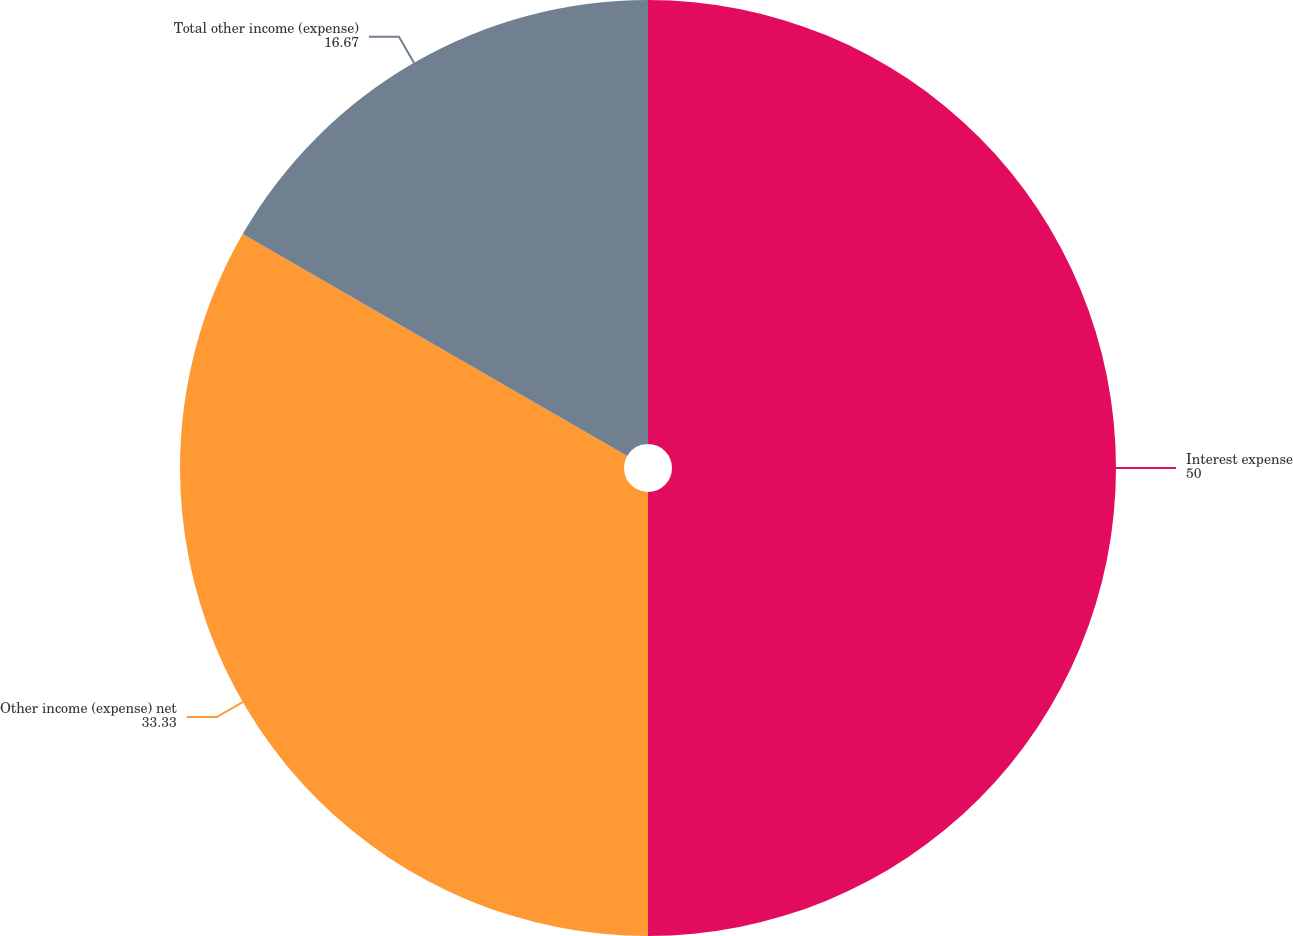Convert chart to OTSL. <chart><loc_0><loc_0><loc_500><loc_500><pie_chart><fcel>Interest expense<fcel>Other income (expense) net<fcel>Total other income (expense)<nl><fcel>50.0%<fcel>33.33%<fcel>16.67%<nl></chart> 